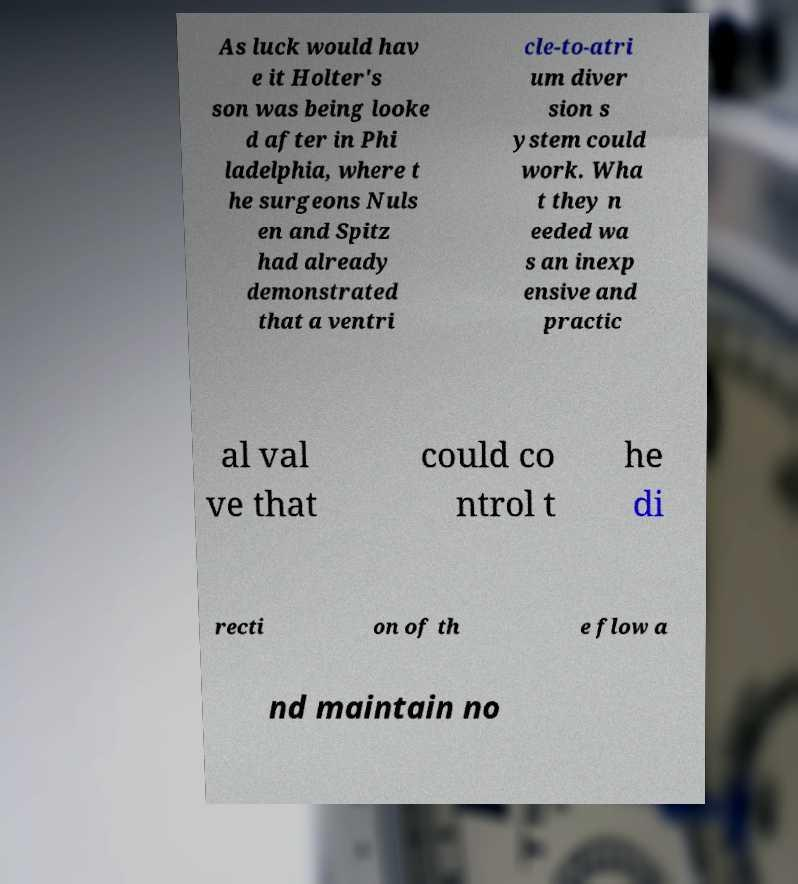I need the written content from this picture converted into text. Can you do that? As luck would hav e it Holter's son was being looke d after in Phi ladelphia, where t he surgeons Nuls en and Spitz had already demonstrated that a ventri cle-to-atri um diver sion s ystem could work. Wha t they n eeded wa s an inexp ensive and practic al val ve that could co ntrol t he di recti on of th e flow a nd maintain no 